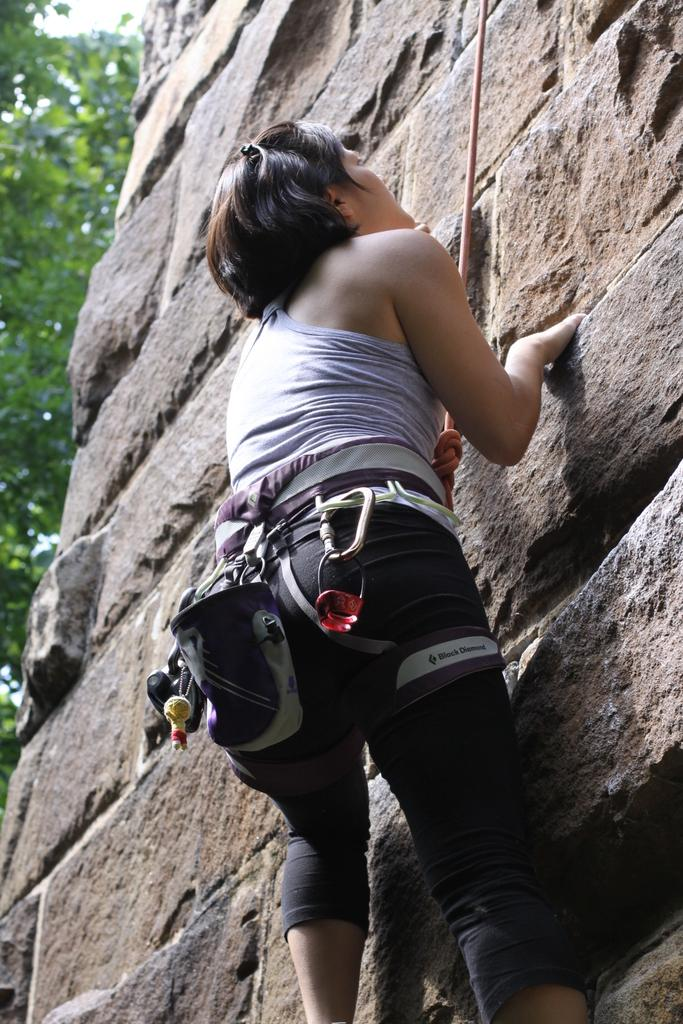Who is the main subject in the image? There is a person in the image. What is the person doing in the image? The person is climbing a wall. What can be seen in the background of the image? There are trees in the background of the image. What type of soap is the person using to climb the wall in the image? There is no soap present in the image, and the person is not using any to climb the wall. 